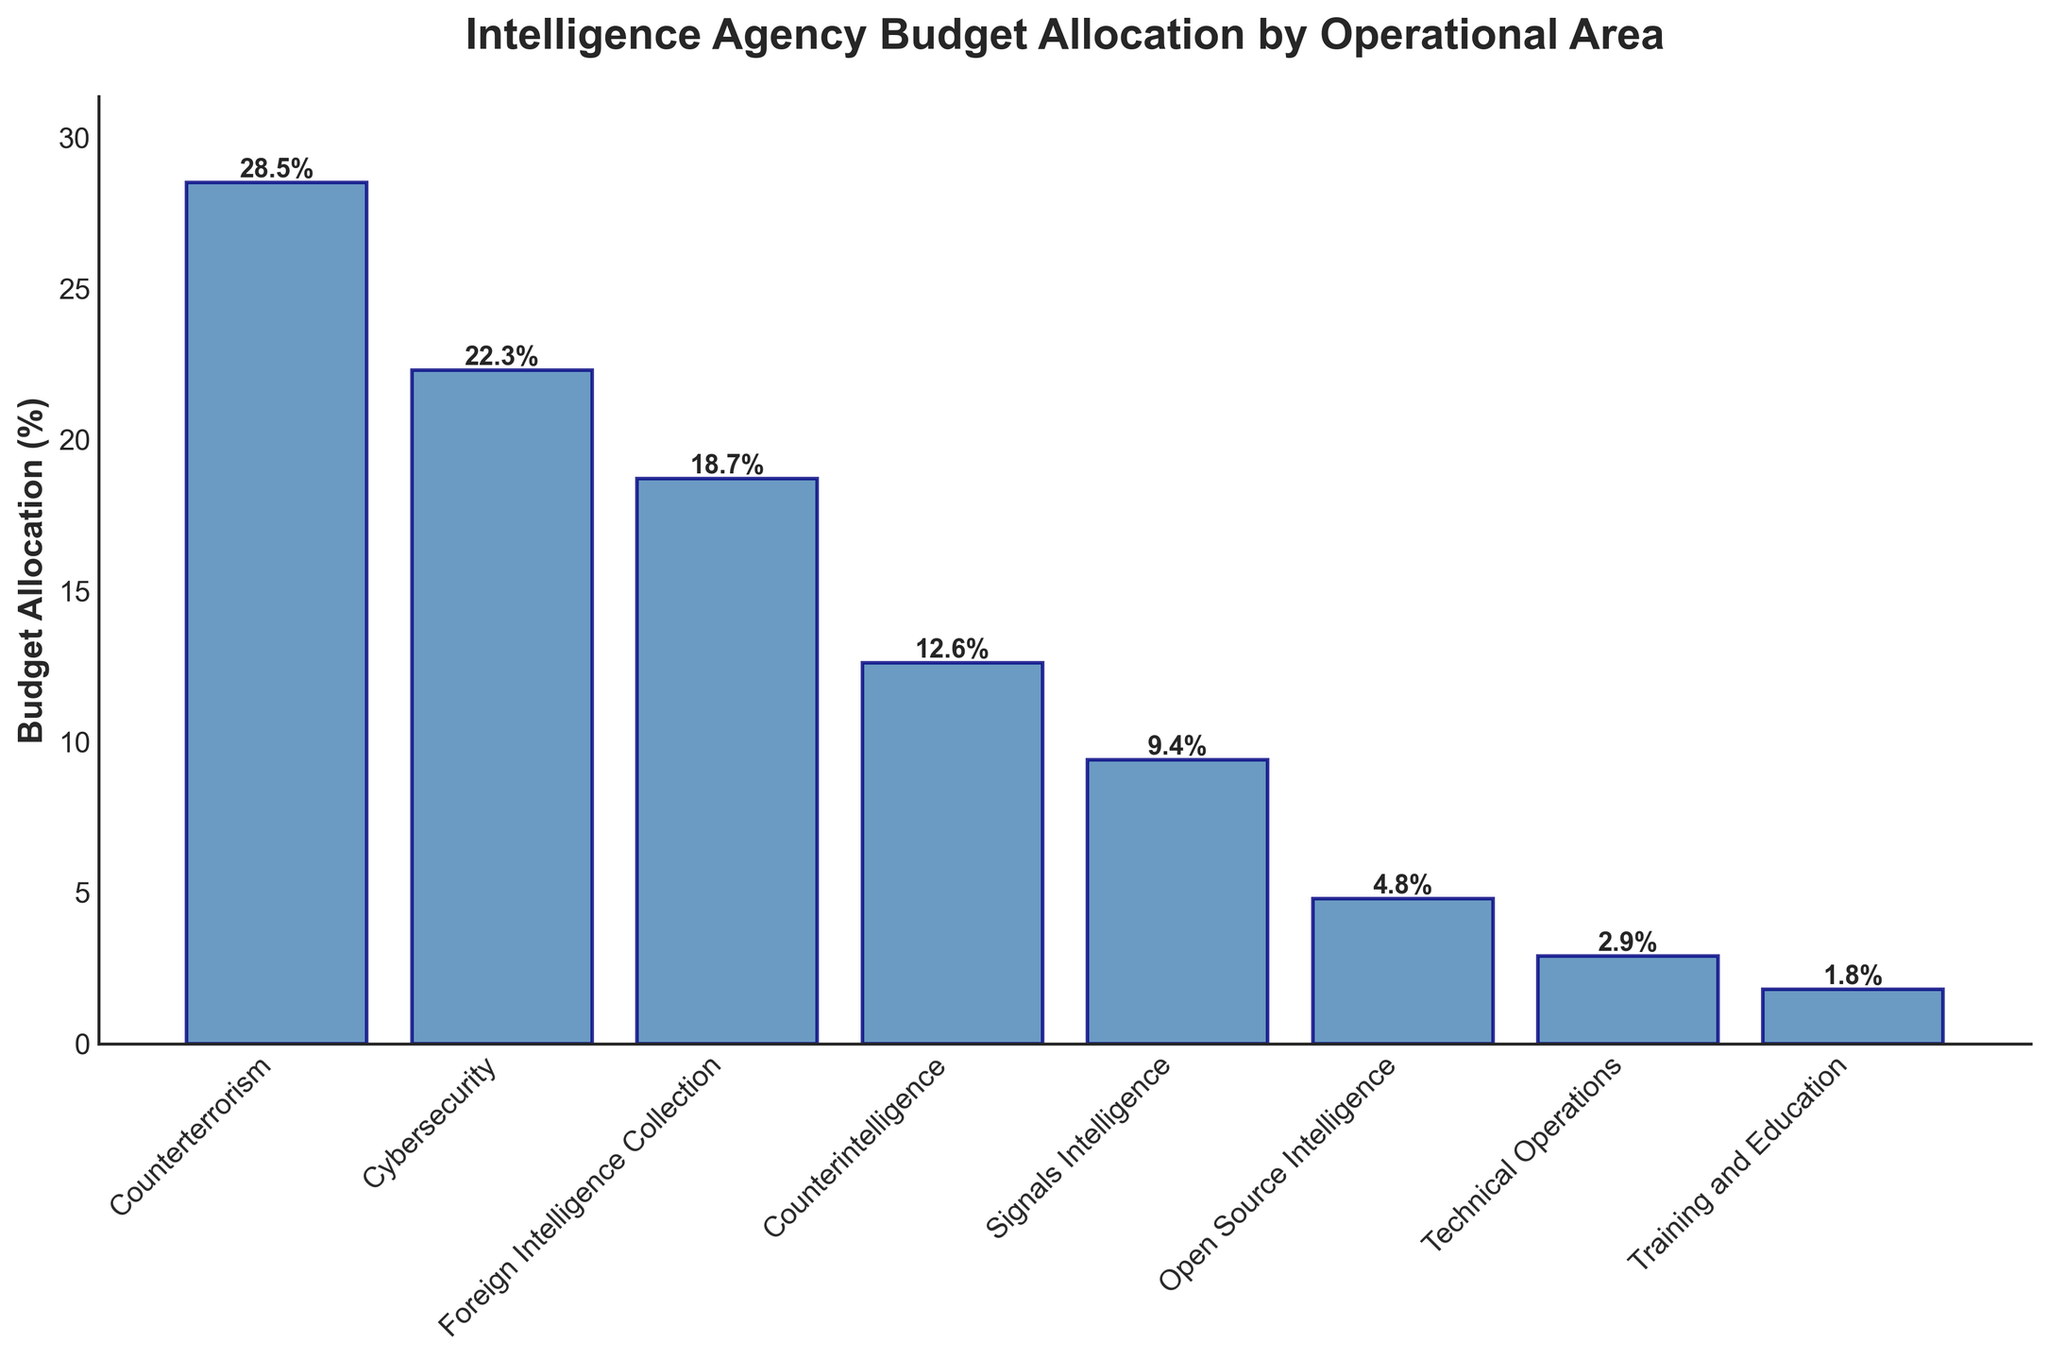What is the operational area with the highest budget allocation? The operational area with the highest budget allocation is the one with the tallest bar in the chart. The tallest bar corresponds to "Counterterrorism" with a value of 28.5%.
Answer: Counterterrorism How much more is allocated to Counterterrorism than to Cybersecurity? Look at the heights of the bars for Counterterrorism and Cybersecurity. Counterterrorism is allocated 28.5%, and Cybersecurity is allocated 22.3%. The difference is calculated as 28.5% - 22.3% = 6.2%.
Answer: 6.2% What is the combined budget allocation for Counterterrorism and Cybersecurity? To find the combined allocation, add the percentages for Counterterrorism and Cybersecurity. Counterterrorism has 28.5%, and Cybersecurity has 22.3%. The combined amount is 28.5% + 22.3% = 50.8%.
Answer: 50.8% Which operational area has the least budget allocation? The operational area with the least budget allocation is the one with the shortest bar in the chart. The shortest bar corresponds to "Training and Education" with a value of 1.8%.
Answer: Training and Education How does the budget allocation for Open Source Intelligence compare to Technical Operations? Open Source Intelligence is allocated 4.8%, while Technical Operations is allocated 2.9%. Comparing the two, Open Source Intelligence has a higher allocation than Technical Operations, specifically: 4.8% - 2.9% = 1.9%.
Answer: Open Source Intelligence has a higher allocation by 1.9% What percentage is allocated to operational areas dealing with intelligence collection and analysis? Add the percentages for areas related to intelligence collection and analysis, which are Foreign Intelligence Collection (18.7%), Signals Intelligence (9.4%), and Open Source Intelligence (4.8%). The total is 18.7% + 9.4% + 4.8% = 32.9%.
Answer: 32.9% How does the budget allocation for Counterintelligence compare to Signals Intelligence? Counterintelligence is allocated 12.6%, while Signals Intelligence is allocated 9.4%. Comparing the two, Counterintelligence has a higher allocation, specifically: 12.6% - 9.4% = 3.2%.
Answer: Counterintelligence has a higher allocation by 3.2% Which operational areas have budget allocations lower than the average? Calculate the average budget allocation, which is 12.625%. The operational areas below this average are: Signals Intelligence (9.4%), Open Source Intelligence (4.8%), Technical Operations (2.9%), and Training and Education (1.8%).
Answer: Signals Intelligence, Open Source Intelligence, Technical Operations, Training and Education 